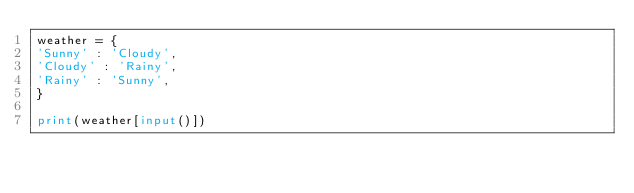Convert code to text. <code><loc_0><loc_0><loc_500><loc_500><_Python_>weather = {
'Sunny' : 'Cloudy',
'Cloudy' : 'Rainy',
'Rainy' : 'Sunny',
}

print(weather[input()])</code> 